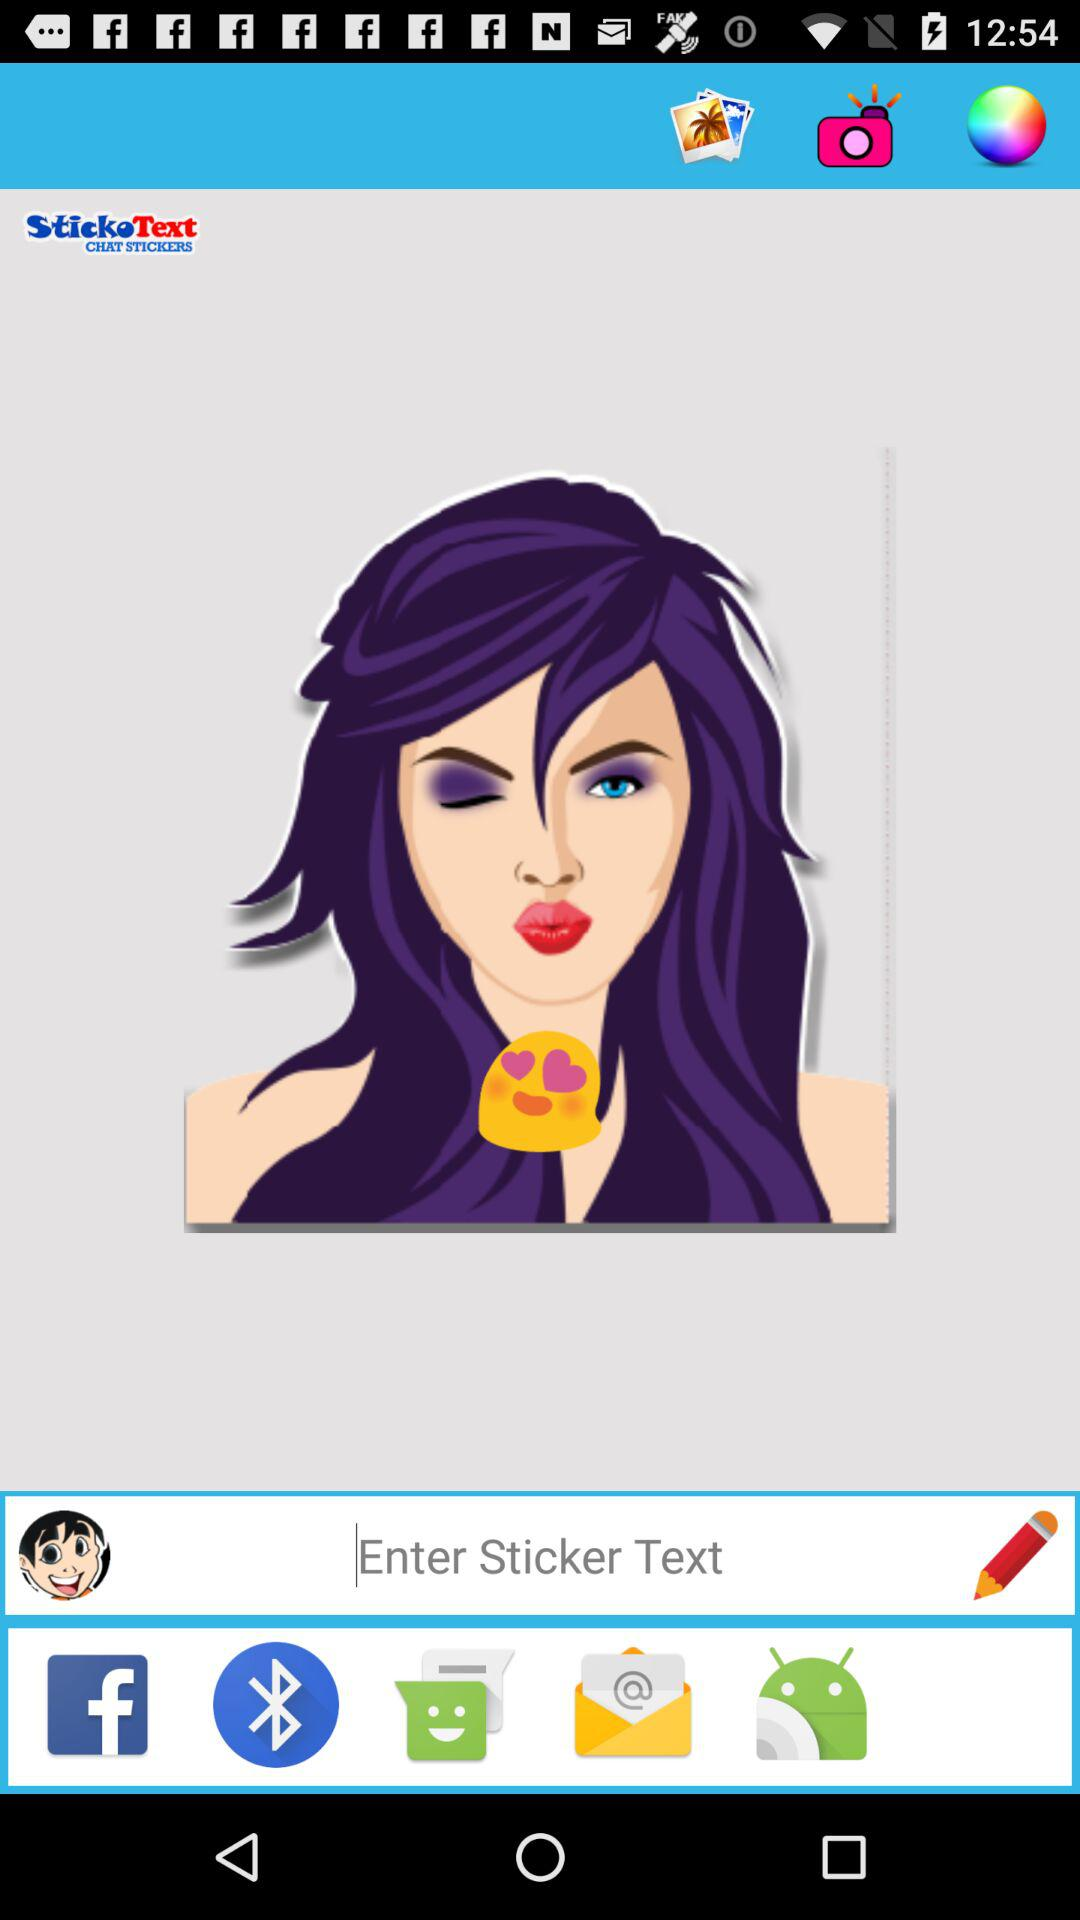What is the application name? The application name is "StickoText CHAT STICKERS". 